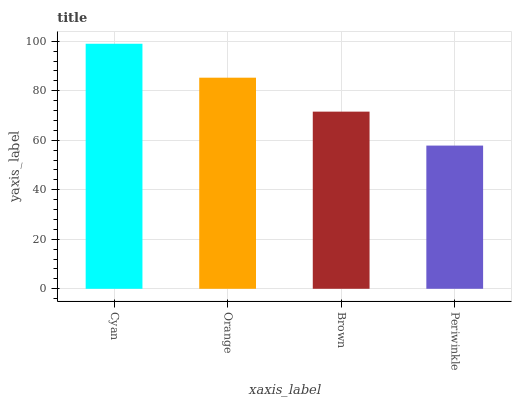Is Periwinkle the minimum?
Answer yes or no. Yes. Is Cyan the maximum?
Answer yes or no. Yes. Is Orange the minimum?
Answer yes or no. No. Is Orange the maximum?
Answer yes or no. No. Is Cyan greater than Orange?
Answer yes or no. Yes. Is Orange less than Cyan?
Answer yes or no. Yes. Is Orange greater than Cyan?
Answer yes or no. No. Is Cyan less than Orange?
Answer yes or no. No. Is Orange the high median?
Answer yes or no. Yes. Is Brown the low median?
Answer yes or no. Yes. Is Brown the high median?
Answer yes or no. No. Is Cyan the low median?
Answer yes or no. No. 